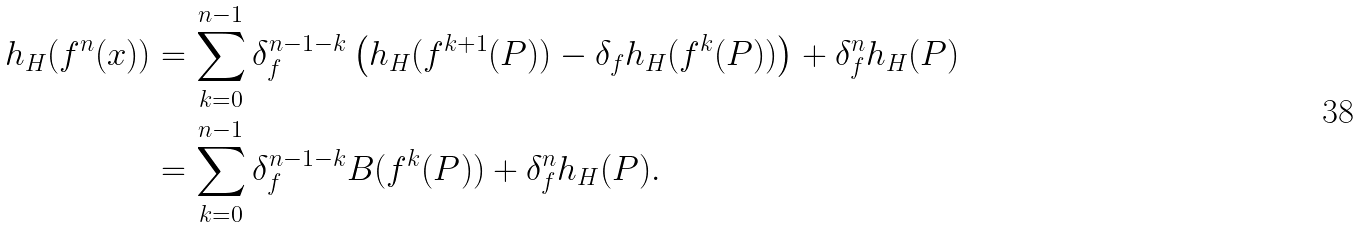Convert formula to latex. <formula><loc_0><loc_0><loc_500><loc_500>h _ { H } ( f ^ { n } ( x ) ) & = \sum _ { k = 0 } ^ { n - 1 } \delta _ { f } ^ { n - 1 - k } \left ( h _ { H } ( f ^ { k + 1 } ( P ) ) - \delta _ { f } h _ { H } ( f ^ { k } ( P ) ) \right ) + \delta _ { f } ^ { n } h _ { H } ( P ) \\ & = \sum _ { k = 0 } ^ { n - 1 } \delta _ { f } ^ { n - 1 - k } B ( f ^ { k } ( P ) ) + \delta _ { f } ^ { n } h _ { H } ( P ) .</formula> 